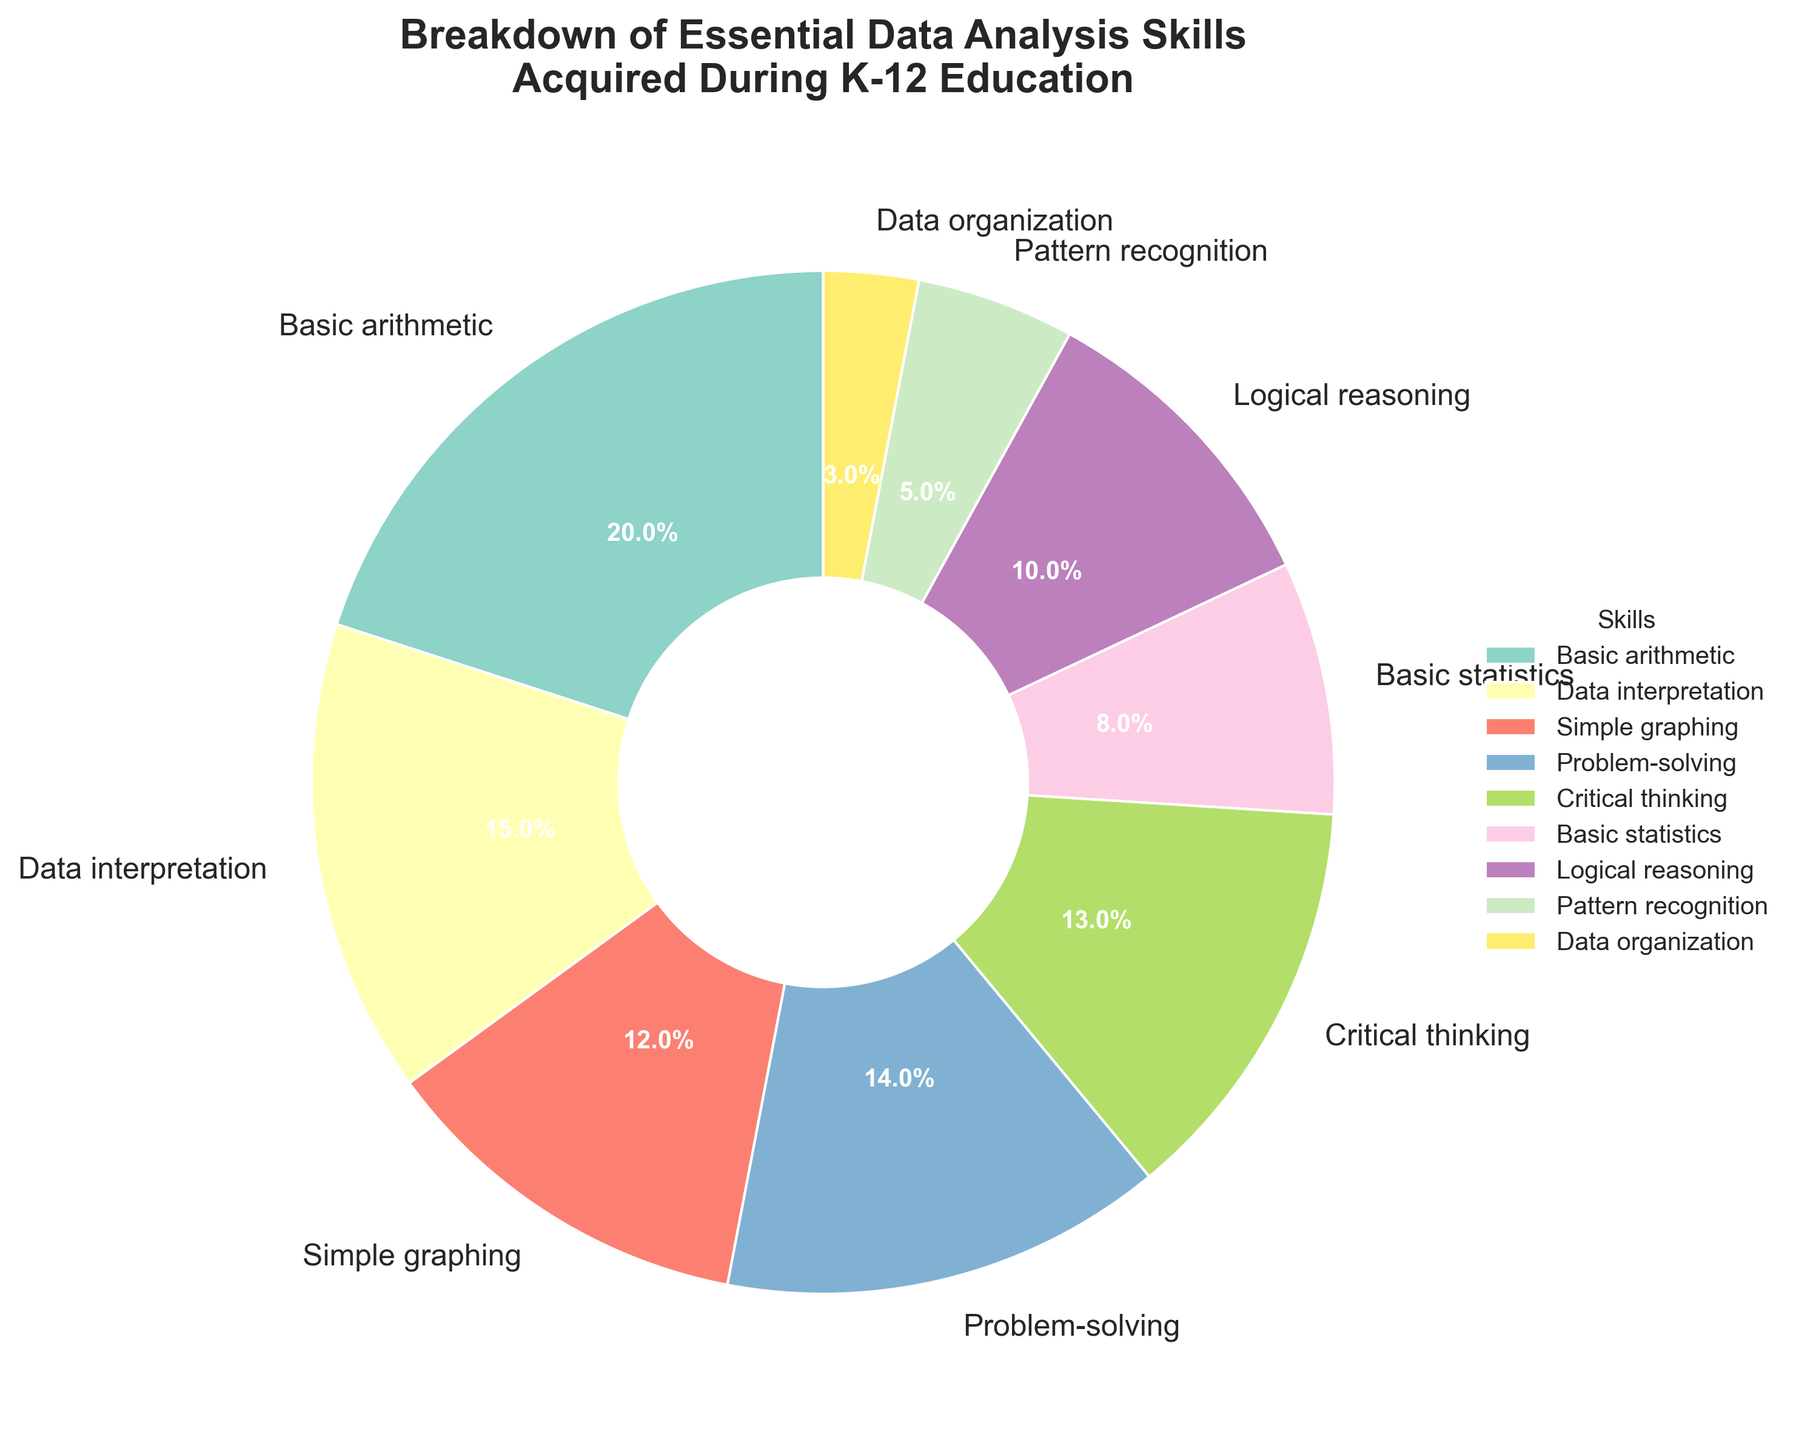What percentage of essential data analysis skills is attributed to Logical reasoning in K-12 education? From the figure, Logical reasoning is one section of the pie chart with a label indicating its percentage.
Answer: 10% Which skill has the highest percentage in the figure, and what is that percentage? By looking at the pie chart, identify the largest section and its corresponding label. Basic arithmetic covers the largest part.
Answer: Basic arithmetic, 20% What's the combined percentage of Data interpretation and Problem-solving skills? Identify the percentages labeled for Data interpretation (15%) and Problem-solving (14%) on the pie chart. Add these two values together: 15% + 14% = 29%.
Answer: 29% Are there more skills that individually account for 10% or more than those that account for less than 10%? Count the number of skills with labels 10% or more: Basic arithmetic (20%), Data interpretation (15%), Simple graphing (12%), Problem-solving (14%), Critical thinking (13%), Logical reasoning (10%). This gives 6 skills. Now, count the skills less than 10%: Basic statistics (8%), Pattern recognition (5%), Data organization (3%). This gives 3 skills.
Answer: More skills account for 10% or more Which skill is represented by the smallest section of the pie chart, and what is its percentage? Locate the smallest segment and its label in the pie chart. Data organization is the smallest section.
Answer: Data organization, 3% What is the difference in percentage between the highest and lowest skills? The highest skill (Basic arithmetic) has 20%, and the lowest skill (Data organization) has 3%. Calculate the difference: 20% - 3% = 17%.
Answer: 17% Between Data interpretation and Simple graphing, which skill has a higher percentage and by how much? Identify the percentages for Data interpretation (15%) and Simple graphing (12%). Subtract the smaller from the larger: 15% - 12% = 3%.
Answer: Data interpretation, 3% If we were to combine Logical reasoning and Critical thinking, what would the total percentage be? Locate the percentages for Logical reasoning (10%) and Critical thinking (13%) in the pie chart. Add them together: 10% + 13% = 23%.
Answer: 23% Is the percentage of Basic statistics higher or lower than that of Pattern recognition, and by what margin? Compare the percentages of Basic statistics (8%) and Pattern recognition (5%). Subtract the smaller percentage from the larger: 8% - 5% = 3%.
Answer: Higher by 3% 